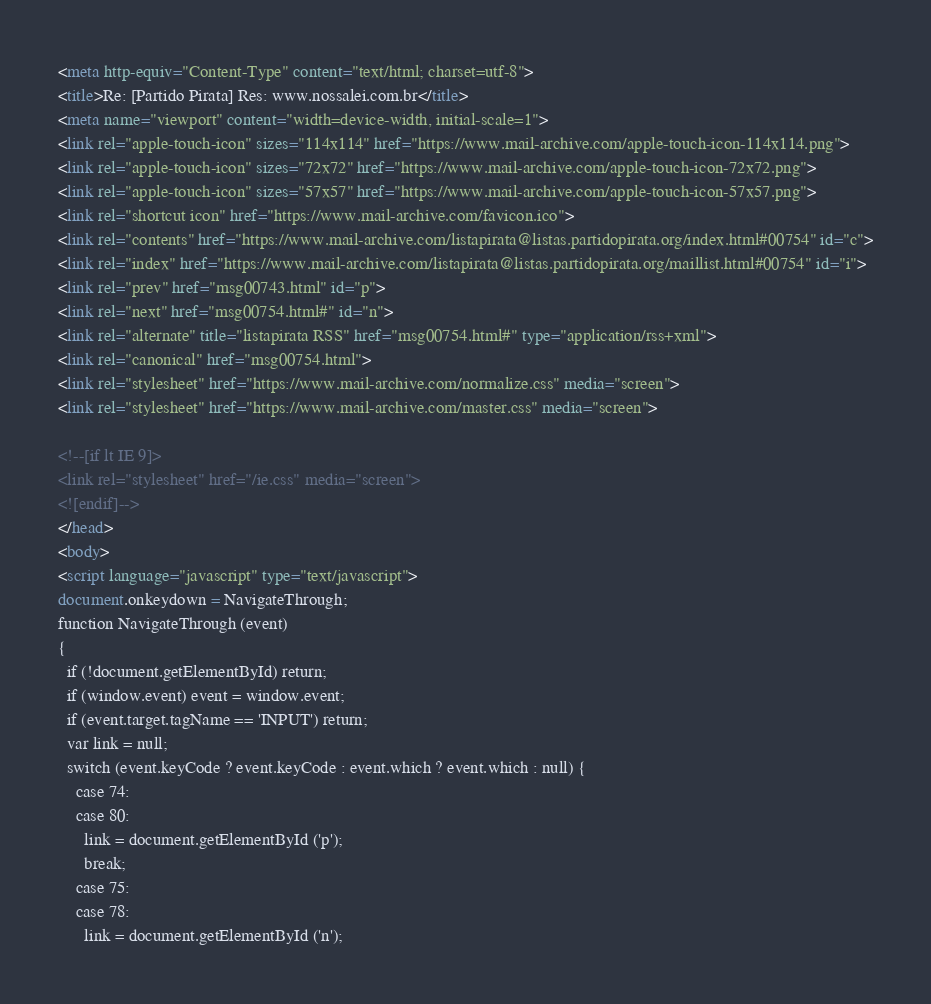Convert code to text. <code><loc_0><loc_0><loc_500><loc_500><_HTML_><meta http-equiv="Content-Type" content="text/html; charset=utf-8">
<title>Re: [Partido Pirata] Res: www.nossalei.com.br</title>
<meta name="viewport" content="width=device-width, initial-scale=1">
<link rel="apple-touch-icon" sizes="114x114" href="https://www.mail-archive.com/apple-touch-icon-114x114.png">
<link rel="apple-touch-icon" sizes="72x72" href="https://www.mail-archive.com/apple-touch-icon-72x72.png">
<link rel="apple-touch-icon" sizes="57x57" href="https://www.mail-archive.com/apple-touch-icon-57x57.png">
<link rel="shortcut icon" href="https://www.mail-archive.com/favicon.ico">
<link rel="contents" href="https://www.mail-archive.com/listapirata@listas.partidopirata.org/index.html#00754" id="c">
<link rel="index" href="https://www.mail-archive.com/listapirata@listas.partidopirata.org/maillist.html#00754" id="i">
<link rel="prev" href="msg00743.html" id="p">
<link rel="next" href="msg00754.html#" id="n">
<link rel="alternate" title="listapirata RSS" href="msg00754.html#" type="application/rss+xml">
<link rel="canonical" href="msg00754.html">
<link rel="stylesheet" href="https://www.mail-archive.com/normalize.css" media="screen">
<link rel="stylesheet" href="https://www.mail-archive.com/master.css" media="screen">

<!--[if lt IE 9]>
<link rel="stylesheet" href="/ie.css" media="screen">
<![endif]-->
</head>
<body>
<script language="javascript" type="text/javascript">
document.onkeydown = NavigateThrough;
function NavigateThrough (event)
{
  if (!document.getElementById) return;
  if (window.event) event = window.event;
  if (event.target.tagName == 'INPUT') return;
  var link = null;
  switch (event.keyCode ? event.keyCode : event.which ? event.which : null) {
    case 74:
    case 80:
      link = document.getElementById ('p');
      break;
    case 75:
    case 78:
      link = document.getElementById ('n');</code> 